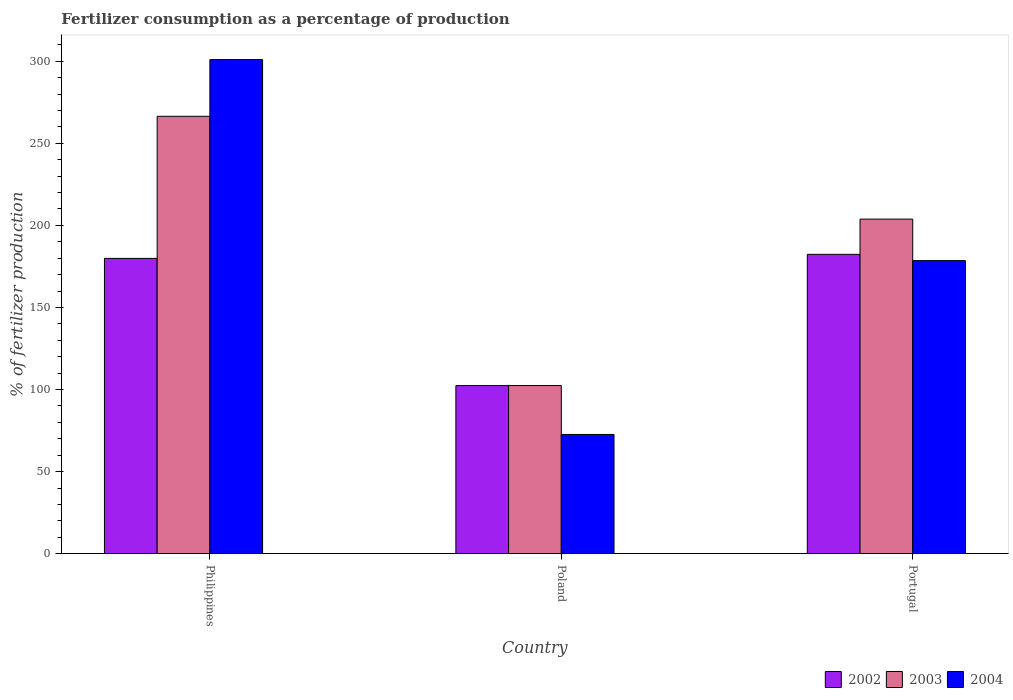How many different coloured bars are there?
Give a very brief answer. 3. How many groups of bars are there?
Give a very brief answer. 3. Are the number of bars on each tick of the X-axis equal?
Ensure brevity in your answer.  Yes. How many bars are there on the 3rd tick from the right?
Your response must be concise. 3. What is the percentage of fertilizers consumed in 2004 in Philippines?
Your response must be concise. 301.04. Across all countries, what is the maximum percentage of fertilizers consumed in 2002?
Ensure brevity in your answer.  182.38. Across all countries, what is the minimum percentage of fertilizers consumed in 2003?
Ensure brevity in your answer.  102.42. In which country was the percentage of fertilizers consumed in 2003 minimum?
Provide a short and direct response. Poland. What is the total percentage of fertilizers consumed in 2004 in the graph?
Your answer should be compact. 552.23. What is the difference between the percentage of fertilizers consumed in 2003 in Philippines and that in Portugal?
Offer a terse response. 62.63. What is the difference between the percentage of fertilizers consumed in 2003 in Portugal and the percentage of fertilizers consumed in 2004 in Philippines?
Ensure brevity in your answer.  -97.19. What is the average percentage of fertilizers consumed in 2004 per country?
Give a very brief answer. 184.08. What is the difference between the percentage of fertilizers consumed of/in 2003 and percentage of fertilizers consumed of/in 2004 in Poland?
Offer a very short reply. 29.78. What is the ratio of the percentage of fertilizers consumed in 2003 in Poland to that in Portugal?
Provide a short and direct response. 0.5. Is the percentage of fertilizers consumed in 2003 in Philippines less than that in Poland?
Your answer should be compact. No. What is the difference between the highest and the second highest percentage of fertilizers consumed in 2004?
Ensure brevity in your answer.  -105.91. What is the difference between the highest and the lowest percentage of fertilizers consumed in 2004?
Keep it short and to the point. 228.4. In how many countries, is the percentage of fertilizers consumed in 2004 greater than the average percentage of fertilizers consumed in 2004 taken over all countries?
Your answer should be very brief. 1. What does the 2nd bar from the left in Portugal represents?
Your answer should be very brief. 2003. What does the 2nd bar from the right in Portugal represents?
Provide a short and direct response. 2003. How many bars are there?
Your response must be concise. 9. Are all the bars in the graph horizontal?
Keep it short and to the point. No. What is the difference between two consecutive major ticks on the Y-axis?
Provide a succinct answer. 50. How many legend labels are there?
Keep it short and to the point. 3. What is the title of the graph?
Offer a very short reply. Fertilizer consumption as a percentage of production. Does "1969" appear as one of the legend labels in the graph?
Make the answer very short. No. What is the label or title of the X-axis?
Your response must be concise. Country. What is the label or title of the Y-axis?
Your answer should be very brief. % of fertilizer production. What is the % of fertilizer production of 2002 in Philippines?
Provide a short and direct response. 179.9. What is the % of fertilizer production in 2003 in Philippines?
Provide a succinct answer. 266.48. What is the % of fertilizer production in 2004 in Philippines?
Keep it short and to the point. 301.04. What is the % of fertilizer production in 2002 in Poland?
Provide a succinct answer. 102.4. What is the % of fertilizer production in 2003 in Poland?
Provide a short and direct response. 102.42. What is the % of fertilizer production in 2004 in Poland?
Provide a succinct answer. 72.64. What is the % of fertilizer production in 2002 in Portugal?
Offer a very short reply. 182.38. What is the % of fertilizer production in 2003 in Portugal?
Offer a very short reply. 203.85. What is the % of fertilizer production in 2004 in Portugal?
Keep it short and to the point. 178.55. Across all countries, what is the maximum % of fertilizer production of 2002?
Your answer should be compact. 182.38. Across all countries, what is the maximum % of fertilizer production in 2003?
Offer a terse response. 266.48. Across all countries, what is the maximum % of fertilizer production of 2004?
Provide a succinct answer. 301.04. Across all countries, what is the minimum % of fertilizer production in 2002?
Give a very brief answer. 102.4. Across all countries, what is the minimum % of fertilizer production in 2003?
Keep it short and to the point. 102.42. Across all countries, what is the minimum % of fertilizer production of 2004?
Give a very brief answer. 72.64. What is the total % of fertilizer production of 2002 in the graph?
Offer a very short reply. 464.68. What is the total % of fertilizer production of 2003 in the graph?
Provide a succinct answer. 572.74. What is the total % of fertilizer production in 2004 in the graph?
Your answer should be compact. 552.23. What is the difference between the % of fertilizer production of 2002 in Philippines and that in Poland?
Keep it short and to the point. 77.5. What is the difference between the % of fertilizer production of 2003 in Philippines and that in Poland?
Your answer should be very brief. 164.06. What is the difference between the % of fertilizer production of 2004 in Philippines and that in Poland?
Give a very brief answer. 228.4. What is the difference between the % of fertilizer production in 2002 in Philippines and that in Portugal?
Offer a very short reply. -2.48. What is the difference between the % of fertilizer production of 2003 in Philippines and that in Portugal?
Provide a succinct answer. 62.63. What is the difference between the % of fertilizer production in 2004 in Philippines and that in Portugal?
Provide a short and direct response. 122.49. What is the difference between the % of fertilizer production of 2002 in Poland and that in Portugal?
Make the answer very short. -79.97. What is the difference between the % of fertilizer production of 2003 in Poland and that in Portugal?
Offer a terse response. -101.43. What is the difference between the % of fertilizer production in 2004 in Poland and that in Portugal?
Keep it short and to the point. -105.91. What is the difference between the % of fertilizer production of 2002 in Philippines and the % of fertilizer production of 2003 in Poland?
Provide a short and direct response. 77.48. What is the difference between the % of fertilizer production in 2002 in Philippines and the % of fertilizer production in 2004 in Poland?
Provide a short and direct response. 107.26. What is the difference between the % of fertilizer production in 2003 in Philippines and the % of fertilizer production in 2004 in Poland?
Give a very brief answer. 193.84. What is the difference between the % of fertilizer production of 2002 in Philippines and the % of fertilizer production of 2003 in Portugal?
Offer a very short reply. -23.95. What is the difference between the % of fertilizer production in 2002 in Philippines and the % of fertilizer production in 2004 in Portugal?
Provide a succinct answer. 1.35. What is the difference between the % of fertilizer production in 2003 in Philippines and the % of fertilizer production in 2004 in Portugal?
Offer a very short reply. 87.93. What is the difference between the % of fertilizer production in 2002 in Poland and the % of fertilizer production in 2003 in Portugal?
Your response must be concise. -101.45. What is the difference between the % of fertilizer production of 2002 in Poland and the % of fertilizer production of 2004 in Portugal?
Provide a succinct answer. -76.15. What is the difference between the % of fertilizer production of 2003 in Poland and the % of fertilizer production of 2004 in Portugal?
Offer a very short reply. -76.13. What is the average % of fertilizer production of 2002 per country?
Your answer should be very brief. 154.89. What is the average % of fertilizer production in 2003 per country?
Offer a terse response. 190.91. What is the average % of fertilizer production in 2004 per country?
Give a very brief answer. 184.08. What is the difference between the % of fertilizer production of 2002 and % of fertilizer production of 2003 in Philippines?
Offer a very short reply. -86.58. What is the difference between the % of fertilizer production of 2002 and % of fertilizer production of 2004 in Philippines?
Give a very brief answer. -121.14. What is the difference between the % of fertilizer production of 2003 and % of fertilizer production of 2004 in Philippines?
Provide a short and direct response. -34.56. What is the difference between the % of fertilizer production of 2002 and % of fertilizer production of 2003 in Poland?
Your response must be concise. -0.02. What is the difference between the % of fertilizer production of 2002 and % of fertilizer production of 2004 in Poland?
Offer a terse response. 29.77. What is the difference between the % of fertilizer production in 2003 and % of fertilizer production in 2004 in Poland?
Offer a very short reply. 29.78. What is the difference between the % of fertilizer production in 2002 and % of fertilizer production in 2003 in Portugal?
Ensure brevity in your answer.  -21.47. What is the difference between the % of fertilizer production of 2002 and % of fertilizer production of 2004 in Portugal?
Your response must be concise. 3.83. What is the difference between the % of fertilizer production of 2003 and % of fertilizer production of 2004 in Portugal?
Offer a very short reply. 25.3. What is the ratio of the % of fertilizer production of 2002 in Philippines to that in Poland?
Ensure brevity in your answer.  1.76. What is the ratio of the % of fertilizer production of 2003 in Philippines to that in Poland?
Your answer should be very brief. 2.6. What is the ratio of the % of fertilizer production in 2004 in Philippines to that in Poland?
Your answer should be very brief. 4.14. What is the ratio of the % of fertilizer production in 2002 in Philippines to that in Portugal?
Your answer should be compact. 0.99. What is the ratio of the % of fertilizer production in 2003 in Philippines to that in Portugal?
Offer a very short reply. 1.31. What is the ratio of the % of fertilizer production of 2004 in Philippines to that in Portugal?
Offer a terse response. 1.69. What is the ratio of the % of fertilizer production of 2002 in Poland to that in Portugal?
Offer a very short reply. 0.56. What is the ratio of the % of fertilizer production of 2003 in Poland to that in Portugal?
Your answer should be compact. 0.5. What is the ratio of the % of fertilizer production of 2004 in Poland to that in Portugal?
Make the answer very short. 0.41. What is the difference between the highest and the second highest % of fertilizer production of 2002?
Provide a short and direct response. 2.48. What is the difference between the highest and the second highest % of fertilizer production of 2003?
Provide a short and direct response. 62.63. What is the difference between the highest and the second highest % of fertilizer production in 2004?
Provide a short and direct response. 122.49. What is the difference between the highest and the lowest % of fertilizer production in 2002?
Your response must be concise. 79.97. What is the difference between the highest and the lowest % of fertilizer production in 2003?
Your answer should be compact. 164.06. What is the difference between the highest and the lowest % of fertilizer production of 2004?
Give a very brief answer. 228.4. 